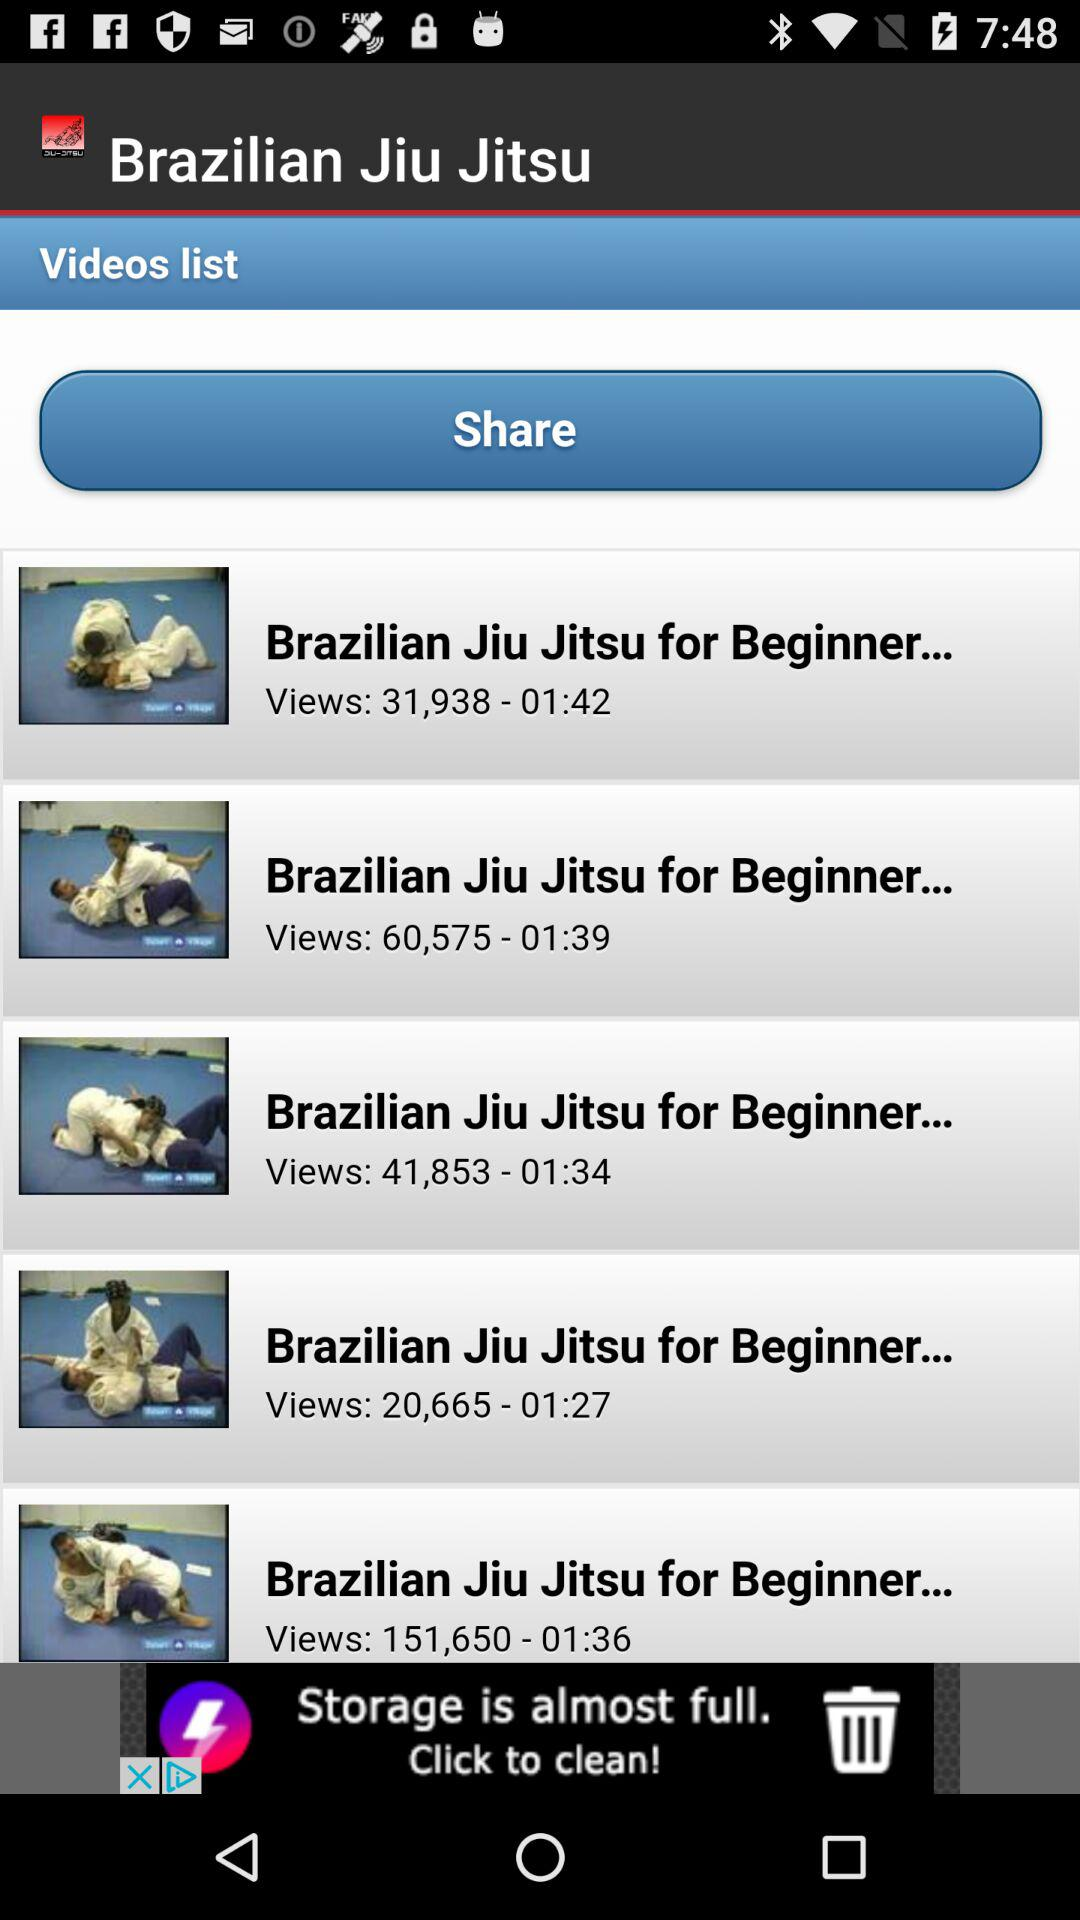How many views are there of "Brazilian Jiu Jitsu for Beginner..." with a duration of 1 minute and 42 seconds? There are 31,938 views of "Brazilian Jiu Jitsu for Beginner..." with a duration of 1 minute and 42 seconds. 